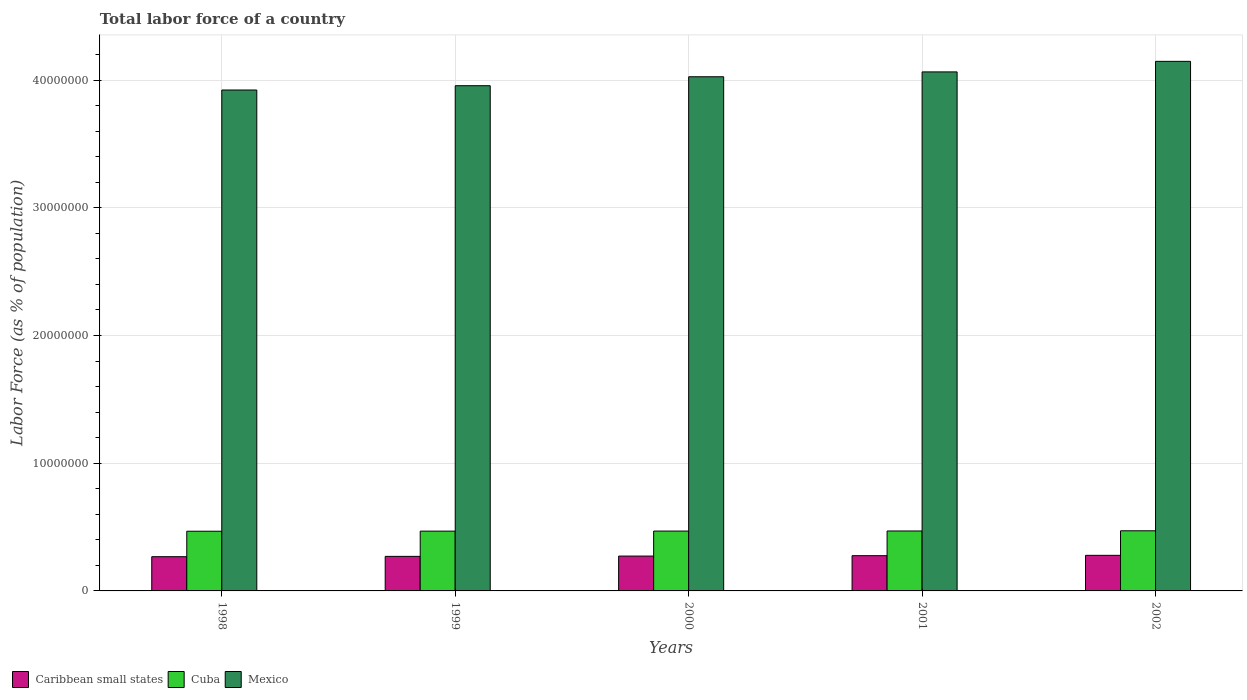How many different coloured bars are there?
Keep it short and to the point. 3. Are the number of bars per tick equal to the number of legend labels?
Offer a terse response. Yes. Are the number of bars on each tick of the X-axis equal?
Your answer should be very brief. Yes. What is the percentage of labor force in Mexico in 2001?
Your answer should be compact. 4.06e+07. Across all years, what is the maximum percentage of labor force in Cuba?
Provide a succinct answer. 4.71e+06. Across all years, what is the minimum percentage of labor force in Cuba?
Make the answer very short. 4.67e+06. In which year was the percentage of labor force in Cuba maximum?
Ensure brevity in your answer.  2002. What is the total percentage of labor force in Cuba in the graph?
Provide a short and direct response. 2.34e+07. What is the difference between the percentage of labor force in Cuba in 1998 and that in 2002?
Provide a succinct answer. -3.49e+04. What is the difference between the percentage of labor force in Caribbean small states in 2000 and the percentage of labor force in Cuba in 2002?
Your response must be concise. -1.98e+06. What is the average percentage of labor force in Mexico per year?
Ensure brevity in your answer.  4.02e+07. In the year 1998, what is the difference between the percentage of labor force in Mexico and percentage of labor force in Caribbean small states?
Provide a short and direct response. 3.65e+07. What is the ratio of the percentage of labor force in Cuba in 2001 to that in 2002?
Provide a succinct answer. 1. Is the percentage of labor force in Mexico in 1998 less than that in 1999?
Keep it short and to the point. Yes. What is the difference between the highest and the second highest percentage of labor force in Caribbean small states?
Provide a short and direct response. 2.66e+04. What is the difference between the highest and the lowest percentage of labor force in Caribbean small states?
Ensure brevity in your answer.  1.06e+05. In how many years, is the percentage of labor force in Mexico greater than the average percentage of labor force in Mexico taken over all years?
Make the answer very short. 3. Is the sum of the percentage of labor force in Mexico in 2001 and 2002 greater than the maximum percentage of labor force in Cuba across all years?
Provide a succinct answer. Yes. What does the 2nd bar from the left in 2000 represents?
Your answer should be compact. Cuba. What does the 1st bar from the right in 1999 represents?
Offer a terse response. Mexico. Is it the case that in every year, the sum of the percentage of labor force in Mexico and percentage of labor force in Cuba is greater than the percentage of labor force in Caribbean small states?
Make the answer very short. Yes. How many bars are there?
Give a very brief answer. 15. What is the difference between two consecutive major ticks on the Y-axis?
Provide a succinct answer. 1.00e+07. Does the graph contain grids?
Your response must be concise. Yes. Where does the legend appear in the graph?
Offer a very short reply. Bottom left. What is the title of the graph?
Keep it short and to the point. Total labor force of a country. What is the label or title of the Y-axis?
Your answer should be compact. Labor Force (as % of population). What is the Labor Force (as % of population) in Caribbean small states in 1998?
Offer a very short reply. 2.68e+06. What is the Labor Force (as % of population) of Cuba in 1998?
Your answer should be compact. 4.67e+06. What is the Labor Force (as % of population) in Mexico in 1998?
Provide a succinct answer. 3.92e+07. What is the Labor Force (as % of population) of Caribbean small states in 1999?
Offer a terse response. 2.71e+06. What is the Labor Force (as % of population) in Cuba in 1999?
Your answer should be compact. 4.68e+06. What is the Labor Force (as % of population) of Mexico in 1999?
Offer a terse response. 3.96e+07. What is the Labor Force (as % of population) in Caribbean small states in 2000?
Provide a succinct answer. 2.73e+06. What is the Labor Force (as % of population) of Cuba in 2000?
Keep it short and to the point. 4.69e+06. What is the Labor Force (as % of population) of Mexico in 2000?
Your answer should be compact. 4.03e+07. What is the Labor Force (as % of population) of Caribbean small states in 2001?
Provide a succinct answer. 2.76e+06. What is the Labor Force (as % of population) in Cuba in 2001?
Provide a short and direct response. 4.69e+06. What is the Labor Force (as % of population) in Mexico in 2001?
Your answer should be compact. 4.06e+07. What is the Labor Force (as % of population) of Caribbean small states in 2002?
Provide a succinct answer. 2.79e+06. What is the Labor Force (as % of population) in Cuba in 2002?
Give a very brief answer. 4.71e+06. What is the Labor Force (as % of population) of Mexico in 2002?
Ensure brevity in your answer.  4.15e+07. Across all years, what is the maximum Labor Force (as % of population) in Caribbean small states?
Offer a very short reply. 2.79e+06. Across all years, what is the maximum Labor Force (as % of population) of Cuba?
Make the answer very short. 4.71e+06. Across all years, what is the maximum Labor Force (as % of population) in Mexico?
Offer a terse response. 4.15e+07. Across all years, what is the minimum Labor Force (as % of population) in Caribbean small states?
Keep it short and to the point. 2.68e+06. Across all years, what is the minimum Labor Force (as % of population) in Cuba?
Provide a succinct answer. 4.67e+06. Across all years, what is the minimum Labor Force (as % of population) of Mexico?
Your response must be concise. 3.92e+07. What is the total Labor Force (as % of population) of Caribbean small states in the graph?
Give a very brief answer. 1.37e+07. What is the total Labor Force (as % of population) of Cuba in the graph?
Provide a succinct answer. 2.34e+07. What is the total Labor Force (as % of population) in Mexico in the graph?
Give a very brief answer. 2.01e+08. What is the difference between the Labor Force (as % of population) in Caribbean small states in 1998 and that in 1999?
Your response must be concise. -2.52e+04. What is the difference between the Labor Force (as % of population) of Cuba in 1998 and that in 1999?
Provide a short and direct response. -7082. What is the difference between the Labor Force (as % of population) of Mexico in 1998 and that in 1999?
Keep it short and to the point. -3.37e+05. What is the difference between the Labor Force (as % of population) in Caribbean small states in 1998 and that in 2000?
Offer a very short reply. -4.91e+04. What is the difference between the Labor Force (as % of population) of Cuba in 1998 and that in 2000?
Keep it short and to the point. -1.22e+04. What is the difference between the Labor Force (as % of population) of Mexico in 1998 and that in 2000?
Your answer should be compact. -1.04e+06. What is the difference between the Labor Force (as % of population) of Caribbean small states in 1998 and that in 2001?
Provide a short and direct response. -7.96e+04. What is the difference between the Labor Force (as % of population) in Cuba in 1998 and that in 2001?
Keep it short and to the point. -1.97e+04. What is the difference between the Labor Force (as % of population) of Mexico in 1998 and that in 2001?
Provide a succinct answer. -1.42e+06. What is the difference between the Labor Force (as % of population) in Caribbean small states in 1998 and that in 2002?
Give a very brief answer. -1.06e+05. What is the difference between the Labor Force (as % of population) in Cuba in 1998 and that in 2002?
Keep it short and to the point. -3.49e+04. What is the difference between the Labor Force (as % of population) of Mexico in 1998 and that in 2002?
Provide a succinct answer. -2.24e+06. What is the difference between the Labor Force (as % of population) in Caribbean small states in 1999 and that in 2000?
Provide a succinct answer. -2.39e+04. What is the difference between the Labor Force (as % of population) in Cuba in 1999 and that in 2000?
Offer a very short reply. -5084. What is the difference between the Labor Force (as % of population) in Mexico in 1999 and that in 2000?
Your answer should be very brief. -7.01e+05. What is the difference between the Labor Force (as % of population) in Caribbean small states in 1999 and that in 2001?
Offer a very short reply. -5.44e+04. What is the difference between the Labor Force (as % of population) in Cuba in 1999 and that in 2001?
Offer a terse response. -1.26e+04. What is the difference between the Labor Force (as % of population) in Mexico in 1999 and that in 2001?
Offer a terse response. -1.08e+06. What is the difference between the Labor Force (as % of population) in Caribbean small states in 1999 and that in 2002?
Give a very brief answer. -8.10e+04. What is the difference between the Labor Force (as % of population) of Cuba in 1999 and that in 2002?
Provide a succinct answer. -2.78e+04. What is the difference between the Labor Force (as % of population) of Mexico in 1999 and that in 2002?
Keep it short and to the point. -1.91e+06. What is the difference between the Labor Force (as % of population) of Caribbean small states in 2000 and that in 2001?
Offer a terse response. -3.05e+04. What is the difference between the Labor Force (as % of population) in Cuba in 2000 and that in 2001?
Offer a very short reply. -7510. What is the difference between the Labor Force (as % of population) in Mexico in 2000 and that in 2001?
Keep it short and to the point. -3.80e+05. What is the difference between the Labor Force (as % of population) of Caribbean small states in 2000 and that in 2002?
Your answer should be very brief. -5.71e+04. What is the difference between the Labor Force (as % of population) in Cuba in 2000 and that in 2002?
Provide a succinct answer. -2.27e+04. What is the difference between the Labor Force (as % of population) of Mexico in 2000 and that in 2002?
Your answer should be compact. -1.21e+06. What is the difference between the Labor Force (as % of population) in Caribbean small states in 2001 and that in 2002?
Keep it short and to the point. -2.66e+04. What is the difference between the Labor Force (as % of population) in Cuba in 2001 and that in 2002?
Give a very brief answer. -1.52e+04. What is the difference between the Labor Force (as % of population) of Mexico in 2001 and that in 2002?
Ensure brevity in your answer.  -8.26e+05. What is the difference between the Labor Force (as % of population) of Caribbean small states in 1998 and the Labor Force (as % of population) of Cuba in 1999?
Your answer should be compact. -2.00e+06. What is the difference between the Labor Force (as % of population) of Caribbean small states in 1998 and the Labor Force (as % of population) of Mexico in 1999?
Provide a short and direct response. -3.69e+07. What is the difference between the Labor Force (as % of population) in Cuba in 1998 and the Labor Force (as % of population) in Mexico in 1999?
Make the answer very short. -3.49e+07. What is the difference between the Labor Force (as % of population) of Caribbean small states in 1998 and the Labor Force (as % of population) of Cuba in 2000?
Provide a short and direct response. -2.01e+06. What is the difference between the Labor Force (as % of population) in Caribbean small states in 1998 and the Labor Force (as % of population) in Mexico in 2000?
Give a very brief answer. -3.76e+07. What is the difference between the Labor Force (as % of population) in Cuba in 1998 and the Labor Force (as % of population) in Mexico in 2000?
Give a very brief answer. -3.56e+07. What is the difference between the Labor Force (as % of population) in Caribbean small states in 1998 and the Labor Force (as % of population) in Cuba in 2001?
Provide a short and direct response. -2.01e+06. What is the difference between the Labor Force (as % of population) of Caribbean small states in 1998 and the Labor Force (as % of population) of Mexico in 2001?
Your answer should be compact. -3.80e+07. What is the difference between the Labor Force (as % of population) in Cuba in 1998 and the Labor Force (as % of population) in Mexico in 2001?
Your response must be concise. -3.60e+07. What is the difference between the Labor Force (as % of population) of Caribbean small states in 1998 and the Labor Force (as % of population) of Cuba in 2002?
Keep it short and to the point. -2.03e+06. What is the difference between the Labor Force (as % of population) of Caribbean small states in 1998 and the Labor Force (as % of population) of Mexico in 2002?
Offer a very short reply. -3.88e+07. What is the difference between the Labor Force (as % of population) of Cuba in 1998 and the Labor Force (as % of population) of Mexico in 2002?
Give a very brief answer. -3.68e+07. What is the difference between the Labor Force (as % of population) in Caribbean small states in 1999 and the Labor Force (as % of population) in Cuba in 2000?
Offer a very short reply. -1.98e+06. What is the difference between the Labor Force (as % of population) in Caribbean small states in 1999 and the Labor Force (as % of population) in Mexico in 2000?
Provide a succinct answer. -3.75e+07. What is the difference between the Labor Force (as % of population) in Cuba in 1999 and the Labor Force (as % of population) in Mexico in 2000?
Provide a short and direct response. -3.56e+07. What is the difference between the Labor Force (as % of population) in Caribbean small states in 1999 and the Labor Force (as % of population) in Cuba in 2001?
Give a very brief answer. -1.99e+06. What is the difference between the Labor Force (as % of population) in Caribbean small states in 1999 and the Labor Force (as % of population) in Mexico in 2001?
Provide a short and direct response. -3.79e+07. What is the difference between the Labor Force (as % of population) in Cuba in 1999 and the Labor Force (as % of population) in Mexico in 2001?
Ensure brevity in your answer.  -3.60e+07. What is the difference between the Labor Force (as % of population) in Caribbean small states in 1999 and the Labor Force (as % of population) in Cuba in 2002?
Keep it short and to the point. -2.00e+06. What is the difference between the Labor Force (as % of population) in Caribbean small states in 1999 and the Labor Force (as % of population) in Mexico in 2002?
Your response must be concise. -3.88e+07. What is the difference between the Labor Force (as % of population) in Cuba in 1999 and the Labor Force (as % of population) in Mexico in 2002?
Make the answer very short. -3.68e+07. What is the difference between the Labor Force (as % of population) in Caribbean small states in 2000 and the Labor Force (as % of population) in Cuba in 2001?
Your response must be concise. -1.96e+06. What is the difference between the Labor Force (as % of population) in Caribbean small states in 2000 and the Labor Force (as % of population) in Mexico in 2001?
Ensure brevity in your answer.  -3.79e+07. What is the difference between the Labor Force (as % of population) of Cuba in 2000 and the Labor Force (as % of population) of Mexico in 2001?
Ensure brevity in your answer.  -3.59e+07. What is the difference between the Labor Force (as % of population) of Caribbean small states in 2000 and the Labor Force (as % of population) of Cuba in 2002?
Provide a succinct answer. -1.98e+06. What is the difference between the Labor Force (as % of population) of Caribbean small states in 2000 and the Labor Force (as % of population) of Mexico in 2002?
Your response must be concise. -3.87e+07. What is the difference between the Labor Force (as % of population) of Cuba in 2000 and the Labor Force (as % of population) of Mexico in 2002?
Offer a terse response. -3.68e+07. What is the difference between the Labor Force (as % of population) of Caribbean small states in 2001 and the Labor Force (as % of population) of Cuba in 2002?
Give a very brief answer. -1.95e+06. What is the difference between the Labor Force (as % of population) in Caribbean small states in 2001 and the Labor Force (as % of population) in Mexico in 2002?
Provide a short and direct response. -3.87e+07. What is the difference between the Labor Force (as % of population) of Cuba in 2001 and the Labor Force (as % of population) of Mexico in 2002?
Offer a terse response. -3.68e+07. What is the average Labor Force (as % of population) in Caribbean small states per year?
Your answer should be compact. 2.73e+06. What is the average Labor Force (as % of population) in Cuba per year?
Your response must be concise. 4.69e+06. What is the average Labor Force (as % of population) in Mexico per year?
Your answer should be compact. 4.02e+07. In the year 1998, what is the difference between the Labor Force (as % of population) in Caribbean small states and Labor Force (as % of population) in Cuba?
Offer a terse response. -1.99e+06. In the year 1998, what is the difference between the Labor Force (as % of population) of Caribbean small states and Labor Force (as % of population) of Mexico?
Your answer should be very brief. -3.65e+07. In the year 1998, what is the difference between the Labor Force (as % of population) in Cuba and Labor Force (as % of population) in Mexico?
Ensure brevity in your answer.  -3.45e+07. In the year 1999, what is the difference between the Labor Force (as % of population) of Caribbean small states and Labor Force (as % of population) of Cuba?
Provide a short and direct response. -1.98e+06. In the year 1999, what is the difference between the Labor Force (as % of population) in Caribbean small states and Labor Force (as % of population) in Mexico?
Offer a very short reply. -3.68e+07. In the year 1999, what is the difference between the Labor Force (as % of population) in Cuba and Labor Force (as % of population) in Mexico?
Ensure brevity in your answer.  -3.49e+07. In the year 2000, what is the difference between the Labor Force (as % of population) of Caribbean small states and Labor Force (as % of population) of Cuba?
Your response must be concise. -1.96e+06. In the year 2000, what is the difference between the Labor Force (as % of population) of Caribbean small states and Labor Force (as % of population) of Mexico?
Give a very brief answer. -3.75e+07. In the year 2000, what is the difference between the Labor Force (as % of population) of Cuba and Labor Force (as % of population) of Mexico?
Your answer should be very brief. -3.56e+07. In the year 2001, what is the difference between the Labor Force (as % of population) in Caribbean small states and Labor Force (as % of population) in Cuba?
Give a very brief answer. -1.93e+06. In the year 2001, what is the difference between the Labor Force (as % of population) in Caribbean small states and Labor Force (as % of population) in Mexico?
Your response must be concise. -3.79e+07. In the year 2001, what is the difference between the Labor Force (as % of population) of Cuba and Labor Force (as % of population) of Mexico?
Ensure brevity in your answer.  -3.59e+07. In the year 2002, what is the difference between the Labor Force (as % of population) in Caribbean small states and Labor Force (as % of population) in Cuba?
Your answer should be very brief. -1.92e+06. In the year 2002, what is the difference between the Labor Force (as % of population) in Caribbean small states and Labor Force (as % of population) in Mexico?
Your answer should be very brief. -3.87e+07. In the year 2002, what is the difference between the Labor Force (as % of population) of Cuba and Labor Force (as % of population) of Mexico?
Your answer should be compact. -3.68e+07. What is the ratio of the Labor Force (as % of population) of Caribbean small states in 1998 to that in 1999?
Offer a very short reply. 0.99. What is the ratio of the Labor Force (as % of population) in Mexico in 1998 to that in 1999?
Provide a succinct answer. 0.99. What is the ratio of the Labor Force (as % of population) of Caribbean small states in 1998 to that in 2000?
Provide a short and direct response. 0.98. What is the ratio of the Labor Force (as % of population) in Mexico in 1998 to that in 2000?
Make the answer very short. 0.97. What is the ratio of the Labor Force (as % of population) of Caribbean small states in 1998 to that in 2001?
Your response must be concise. 0.97. What is the ratio of the Labor Force (as % of population) of Cuba in 1998 to that in 2001?
Provide a short and direct response. 1. What is the ratio of the Labor Force (as % of population) of Mexico in 1998 to that in 2001?
Your answer should be very brief. 0.97. What is the ratio of the Labor Force (as % of population) of Caribbean small states in 1998 to that in 2002?
Keep it short and to the point. 0.96. What is the ratio of the Labor Force (as % of population) of Mexico in 1998 to that in 2002?
Provide a short and direct response. 0.95. What is the ratio of the Labor Force (as % of population) of Mexico in 1999 to that in 2000?
Your answer should be very brief. 0.98. What is the ratio of the Labor Force (as % of population) of Caribbean small states in 1999 to that in 2001?
Give a very brief answer. 0.98. What is the ratio of the Labor Force (as % of population) of Mexico in 1999 to that in 2001?
Your answer should be very brief. 0.97. What is the ratio of the Labor Force (as % of population) in Caribbean small states in 1999 to that in 2002?
Give a very brief answer. 0.97. What is the ratio of the Labor Force (as % of population) in Mexico in 1999 to that in 2002?
Provide a short and direct response. 0.95. What is the ratio of the Labor Force (as % of population) of Mexico in 2000 to that in 2001?
Your answer should be compact. 0.99. What is the ratio of the Labor Force (as % of population) in Caribbean small states in 2000 to that in 2002?
Offer a terse response. 0.98. What is the ratio of the Labor Force (as % of population) of Cuba in 2000 to that in 2002?
Keep it short and to the point. 1. What is the ratio of the Labor Force (as % of population) of Mexico in 2000 to that in 2002?
Your answer should be very brief. 0.97. What is the ratio of the Labor Force (as % of population) in Mexico in 2001 to that in 2002?
Give a very brief answer. 0.98. What is the difference between the highest and the second highest Labor Force (as % of population) in Caribbean small states?
Provide a short and direct response. 2.66e+04. What is the difference between the highest and the second highest Labor Force (as % of population) of Cuba?
Offer a very short reply. 1.52e+04. What is the difference between the highest and the second highest Labor Force (as % of population) of Mexico?
Keep it short and to the point. 8.26e+05. What is the difference between the highest and the lowest Labor Force (as % of population) in Caribbean small states?
Your answer should be very brief. 1.06e+05. What is the difference between the highest and the lowest Labor Force (as % of population) in Cuba?
Offer a very short reply. 3.49e+04. What is the difference between the highest and the lowest Labor Force (as % of population) in Mexico?
Keep it short and to the point. 2.24e+06. 